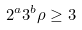<formula> <loc_0><loc_0><loc_500><loc_500>2 ^ { a } 3 ^ { b } \rho \geq 3</formula> 